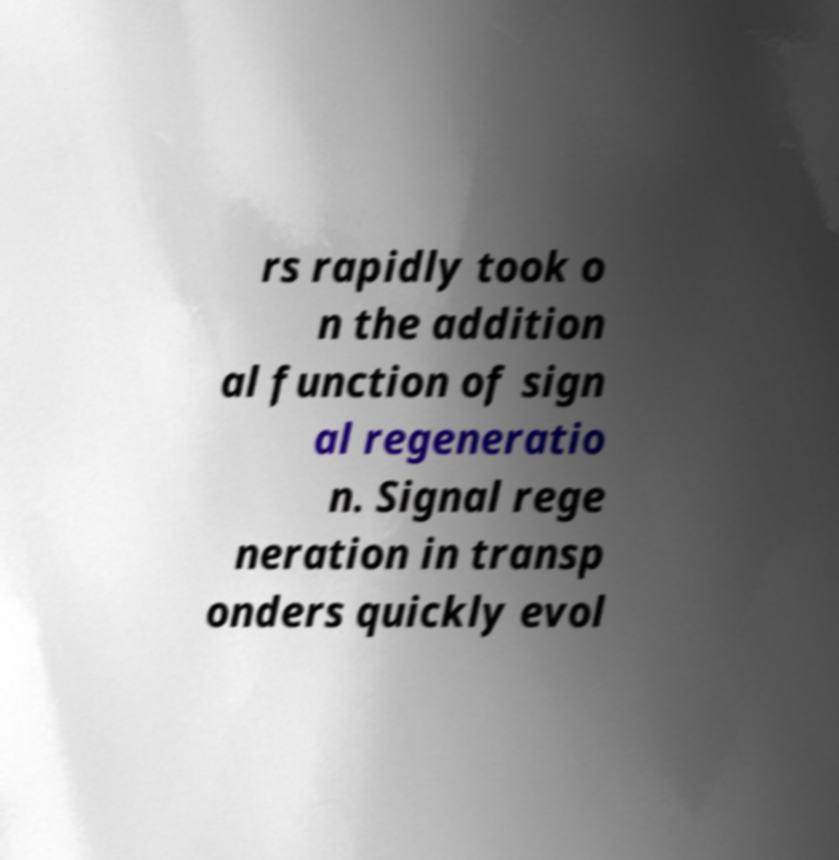For documentation purposes, I need the text within this image transcribed. Could you provide that? rs rapidly took o n the addition al function of sign al regeneratio n. Signal rege neration in transp onders quickly evol 